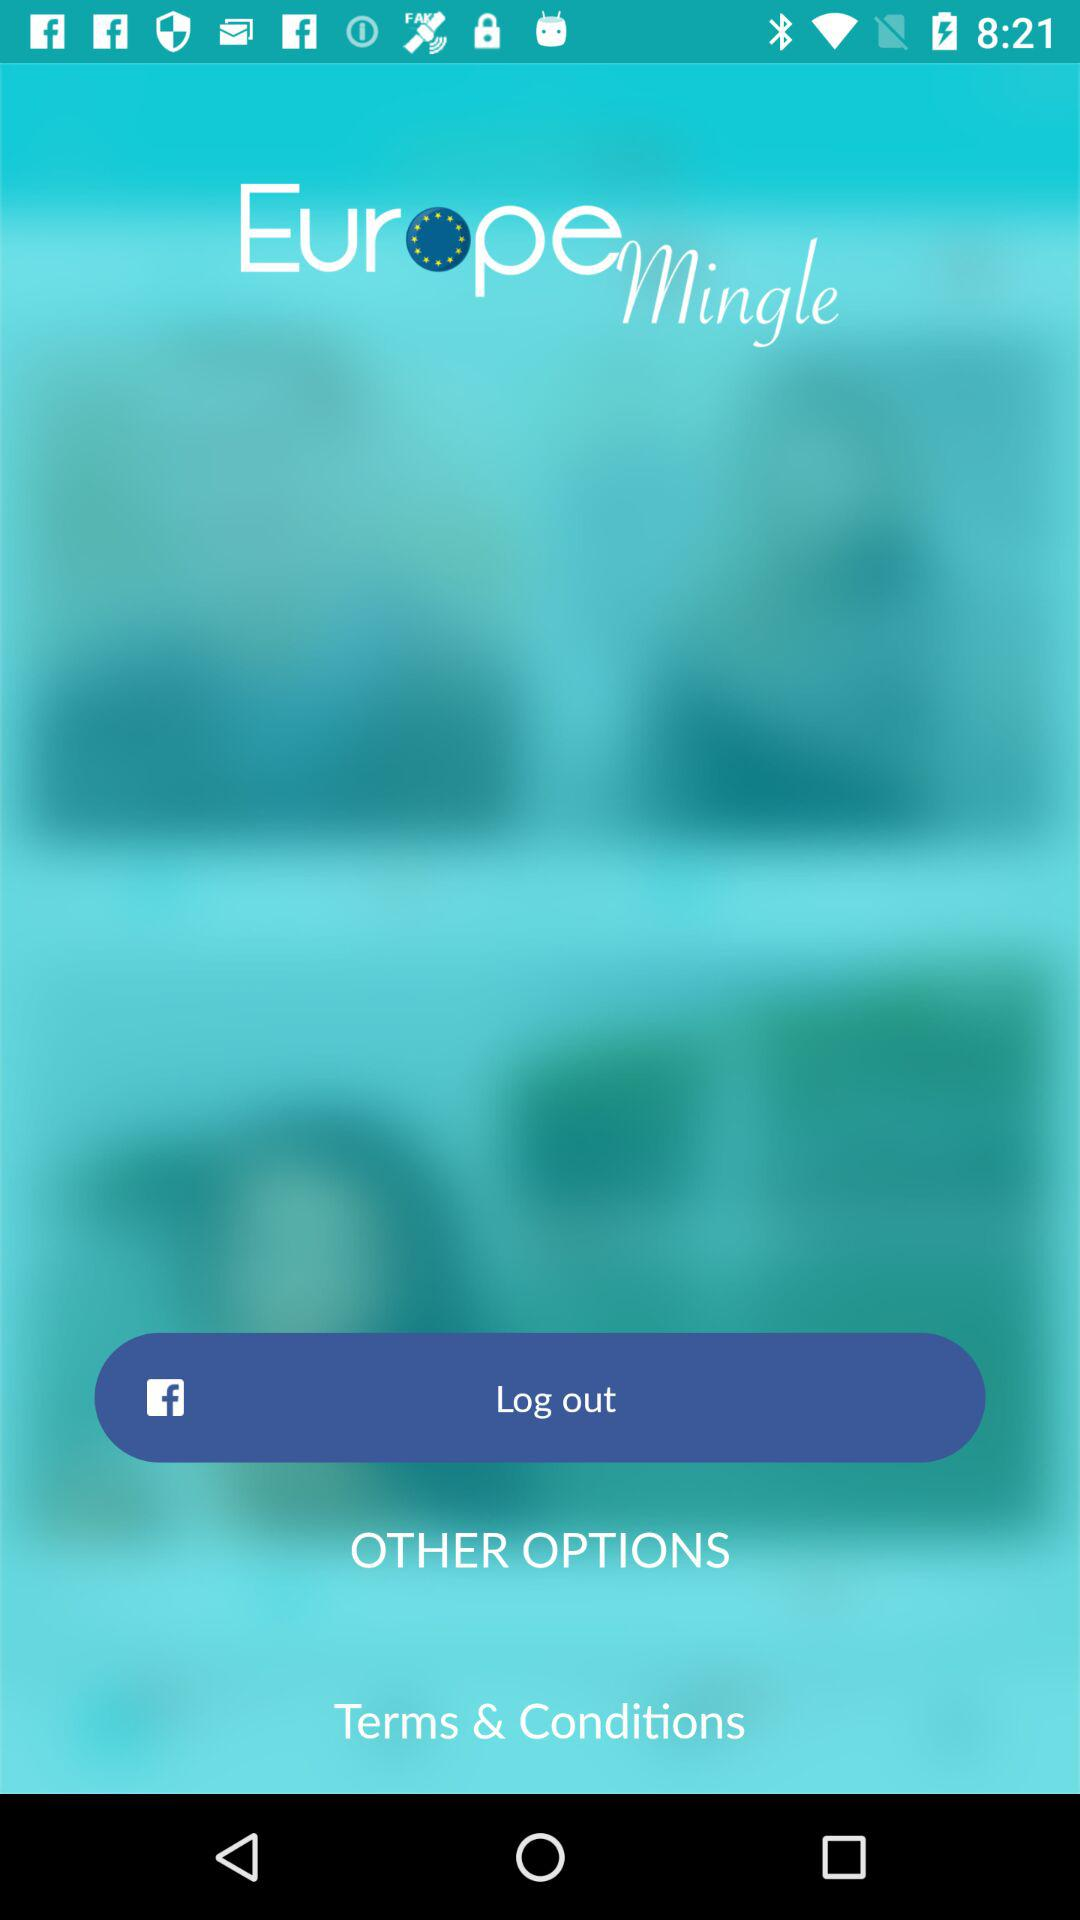Has the user agreed to the terms and conditions?
When the provided information is insufficient, respond with <no answer>. <no answer> 